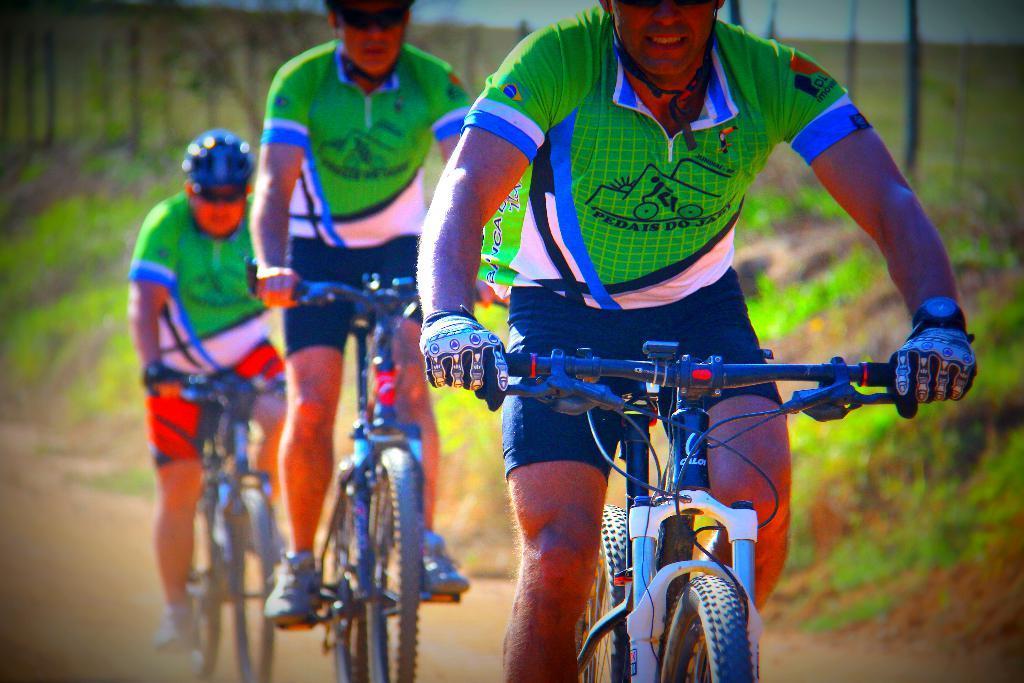In one or two sentences, can you explain what this image depicts? In this image we can see three persons riding bicycles. Behind the persons we can see the grass. The background of the image is blurred. 